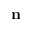<formula> <loc_0><loc_0><loc_500><loc_500>n</formula> 